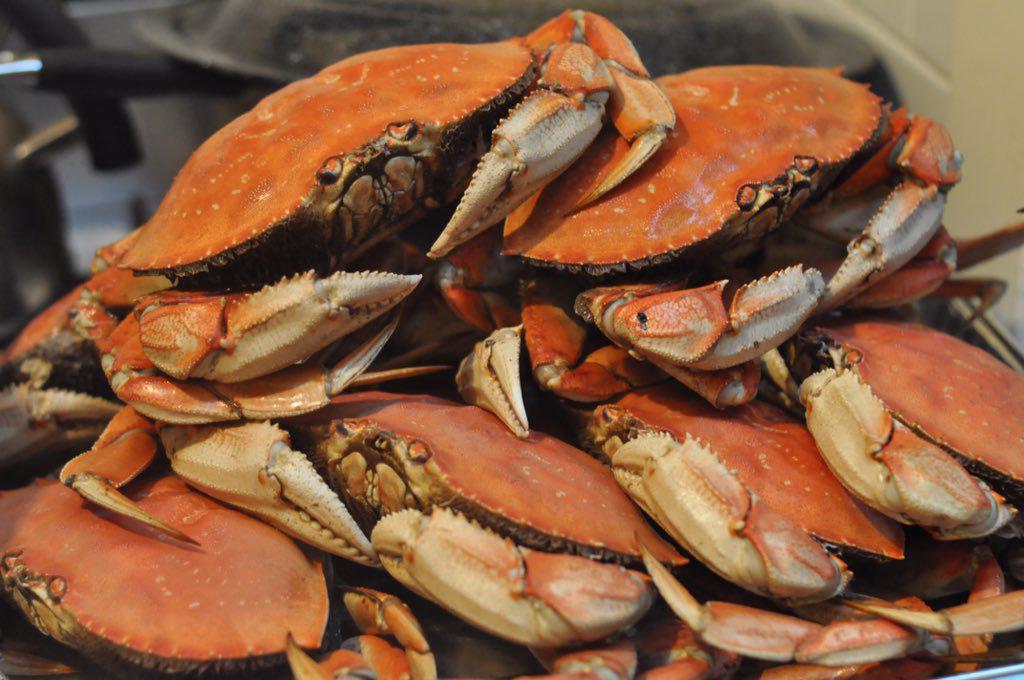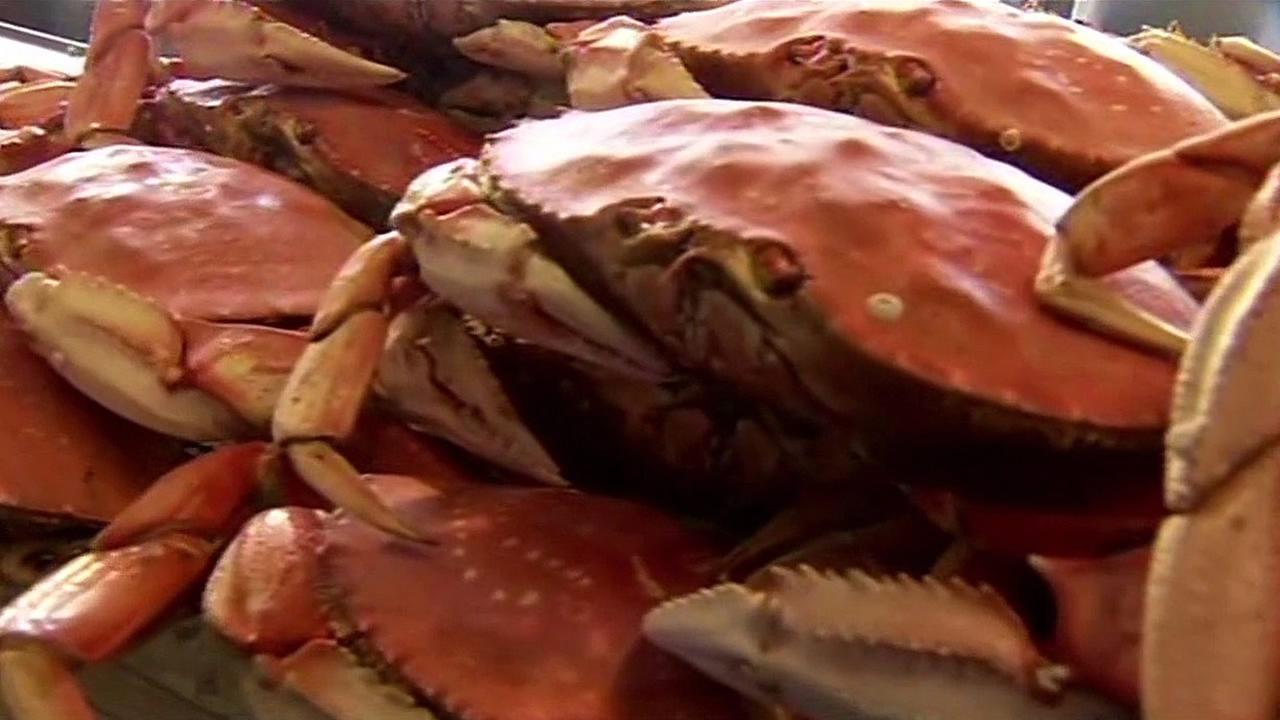The first image is the image on the left, the second image is the image on the right. Assess this claim about the two images: "In the right image, a white rectangular label is overlapping a red-orange-shelled crab that is in some type of container.". Correct or not? Answer yes or no. No. The first image is the image on the left, the second image is the image on the right. For the images shown, is this caption "All the crabs are piled on top of one another." true? Answer yes or no. Yes. 